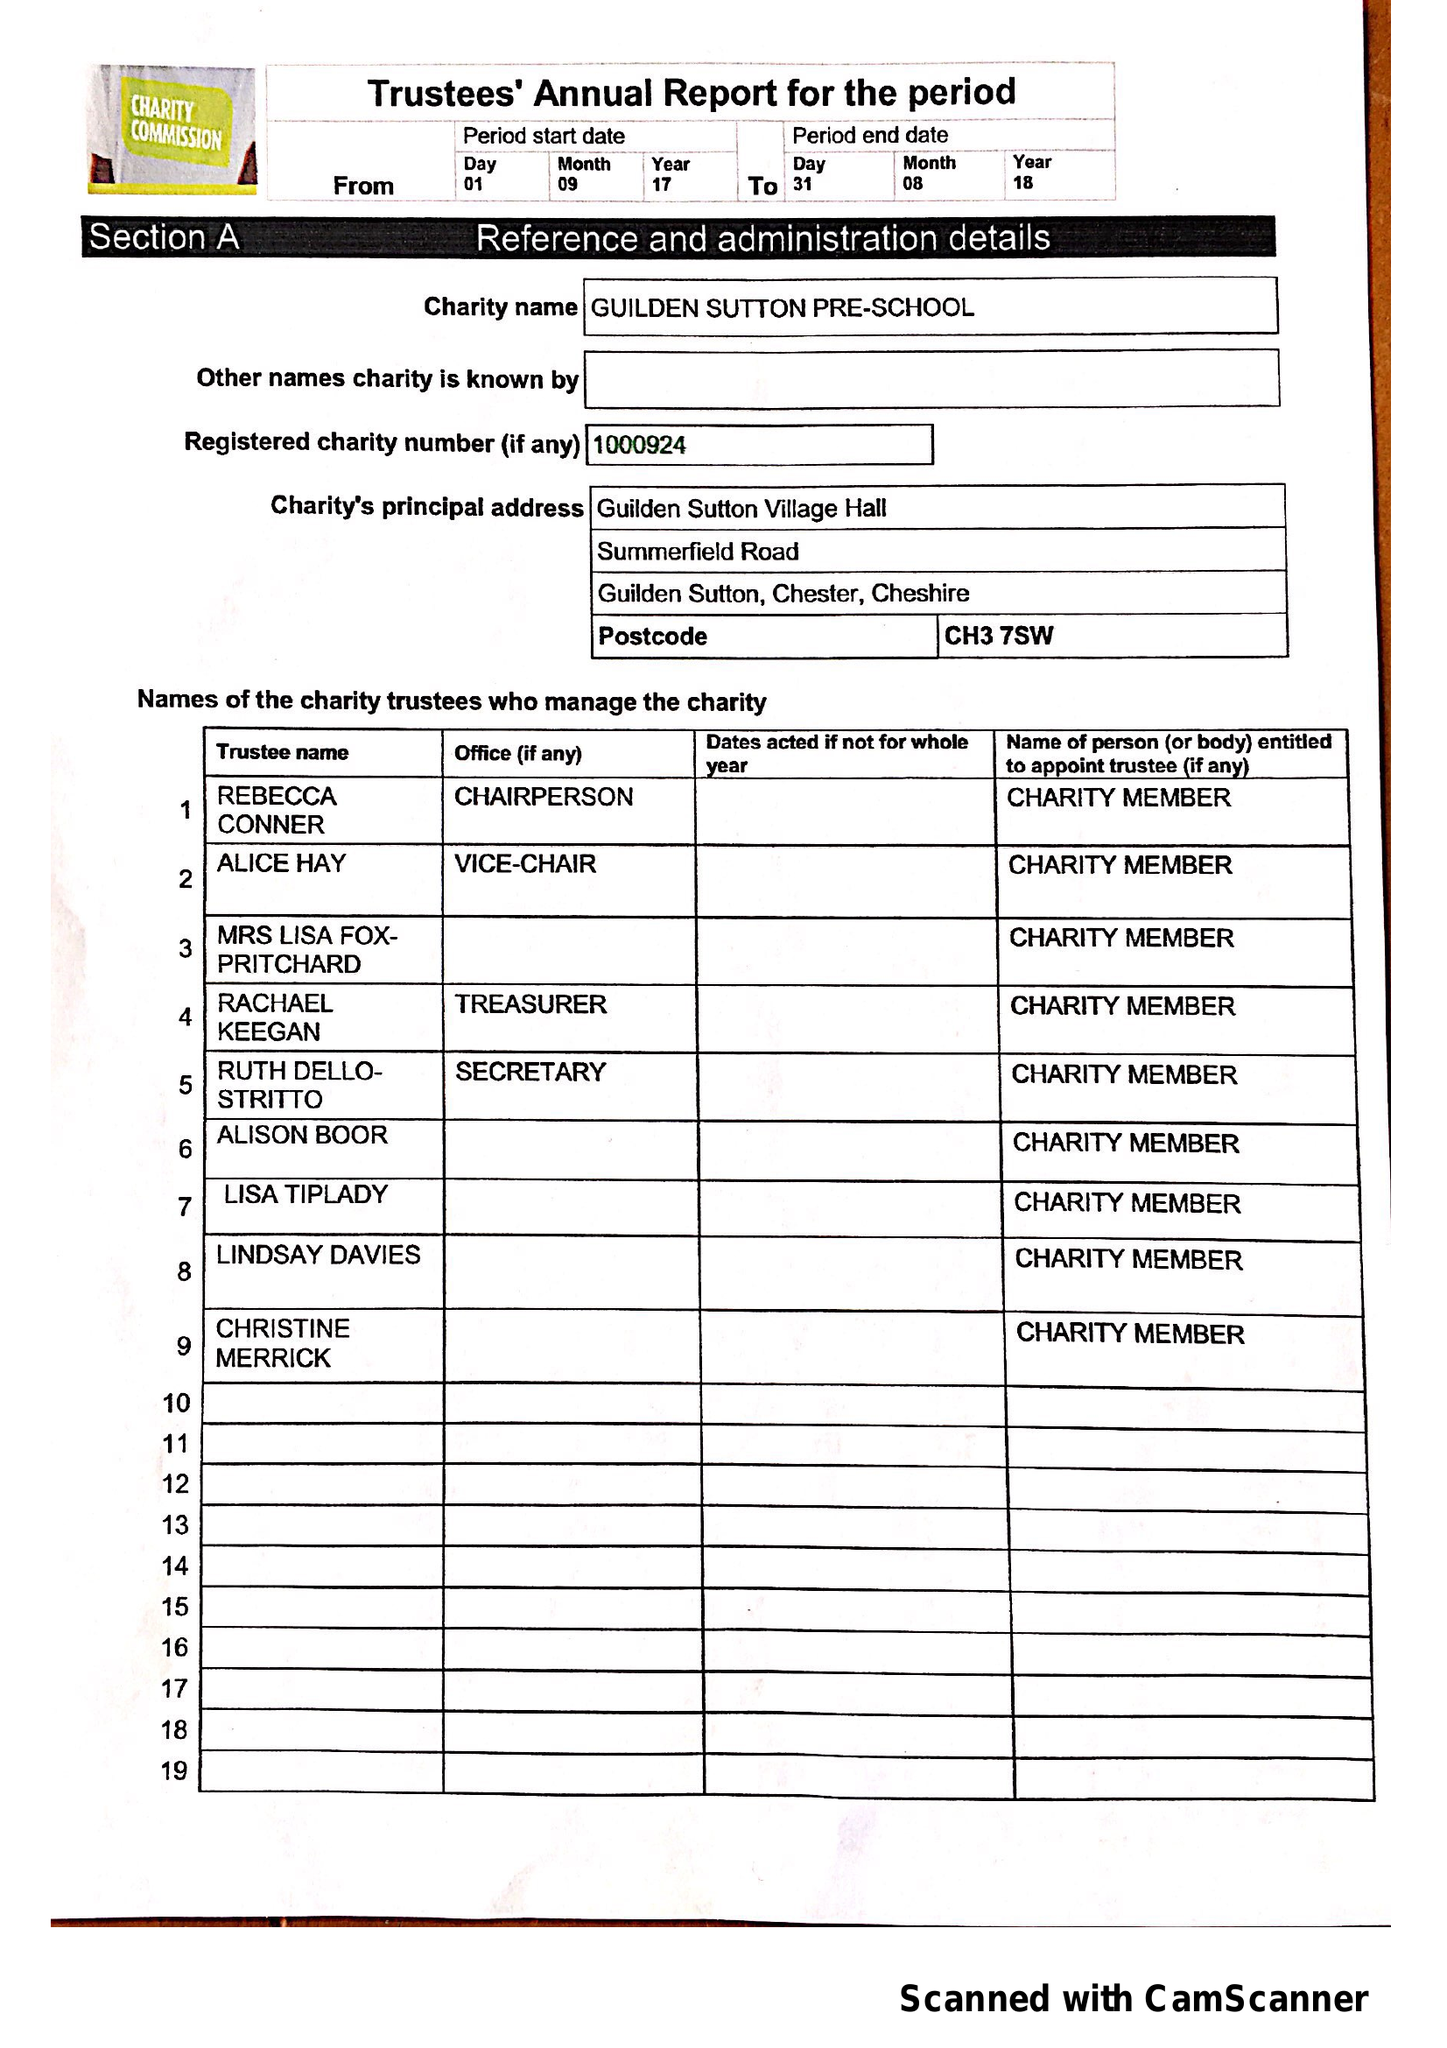What is the value for the charity_number?
Answer the question using a single word or phrase. 1000924 